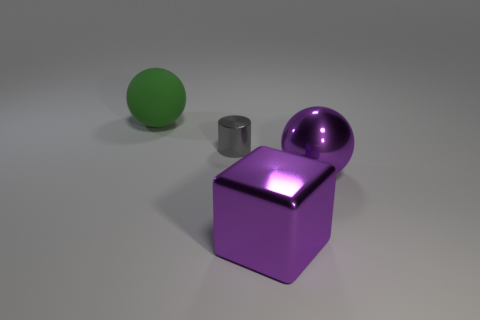Add 1 tiny gray rubber cubes. How many objects exist? 5 Subtract 1 cylinders. How many cylinders are left? 0 Subtract all purple spheres. How many spheres are left? 1 Subtract all blocks. How many objects are left? 3 Subtract all gray cylinders. How many purple spheres are left? 1 Subtract all tiny metallic things. Subtract all tiny red metal blocks. How many objects are left? 3 Add 2 gray shiny things. How many gray shiny things are left? 3 Add 1 large yellow cylinders. How many large yellow cylinders exist? 1 Subtract 0 blue cylinders. How many objects are left? 4 Subtract all blue cubes. Subtract all green spheres. How many cubes are left? 1 